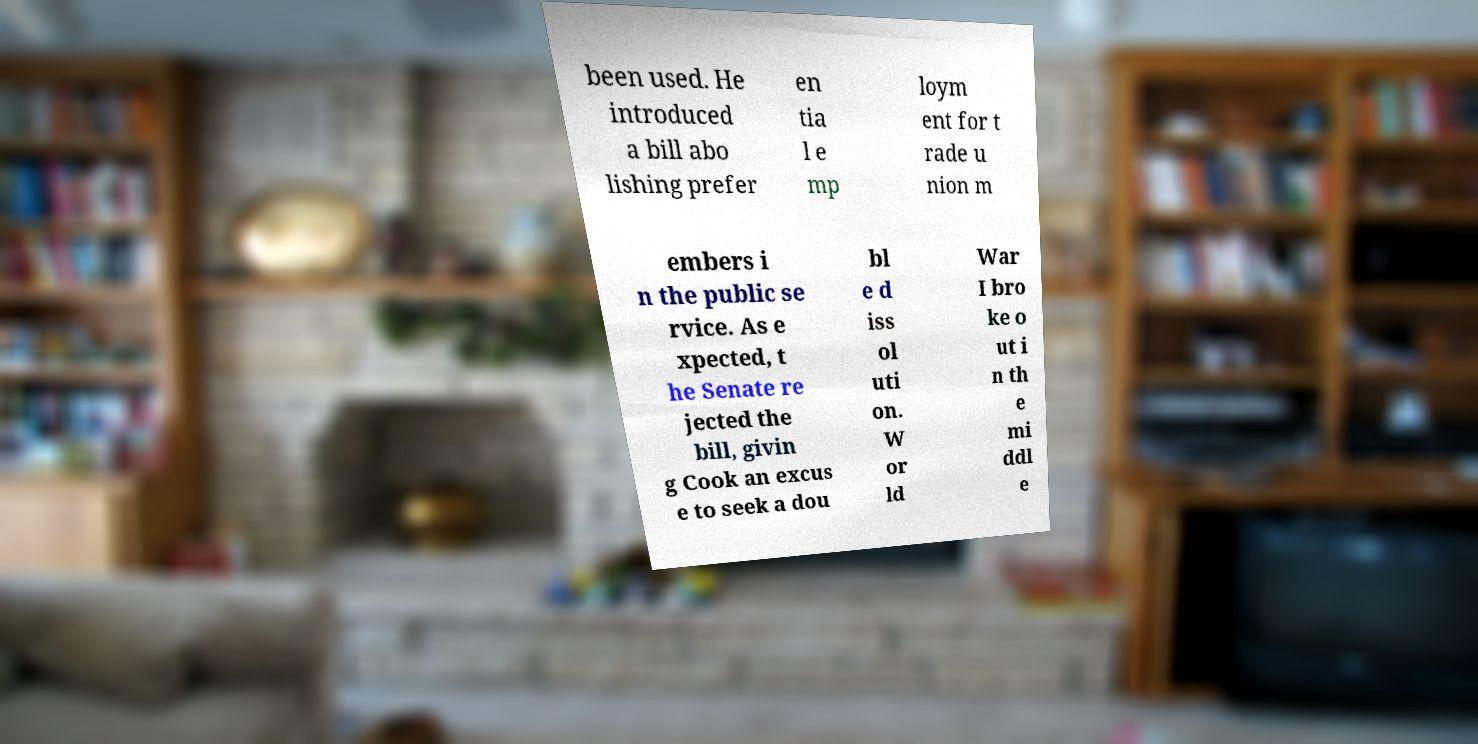Can you accurately transcribe the text from the provided image for me? been used. He introduced a bill abo lishing prefer en tia l e mp loym ent for t rade u nion m embers i n the public se rvice. As e xpected, t he Senate re jected the bill, givin g Cook an excus e to seek a dou bl e d iss ol uti on. W or ld War I bro ke o ut i n th e mi ddl e 